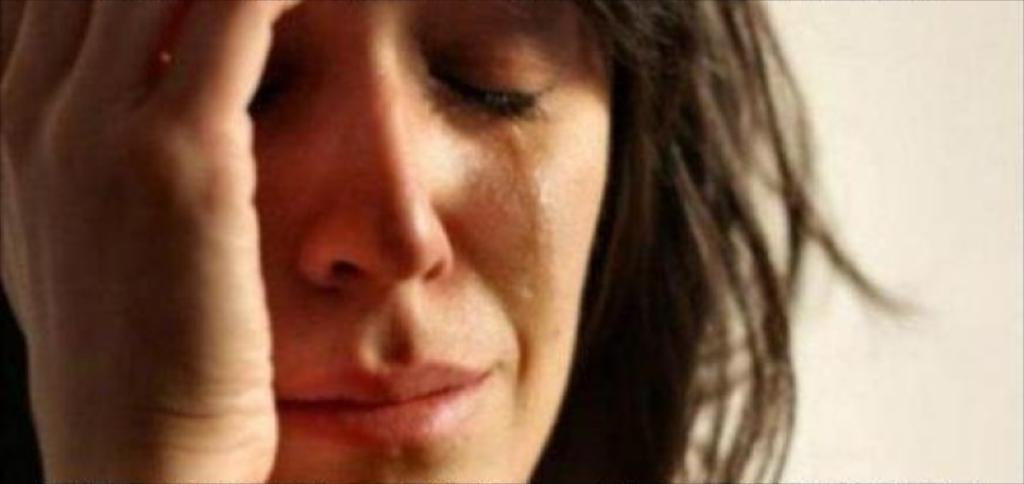What is the main subject of the image? There is a person in the image. Can you describe the setting or environment in the image? There is a background in the image. What is the chance of finding gold in the carriage in the image? There is no carriage or mention of gold in the image; it only features a person and a background. 